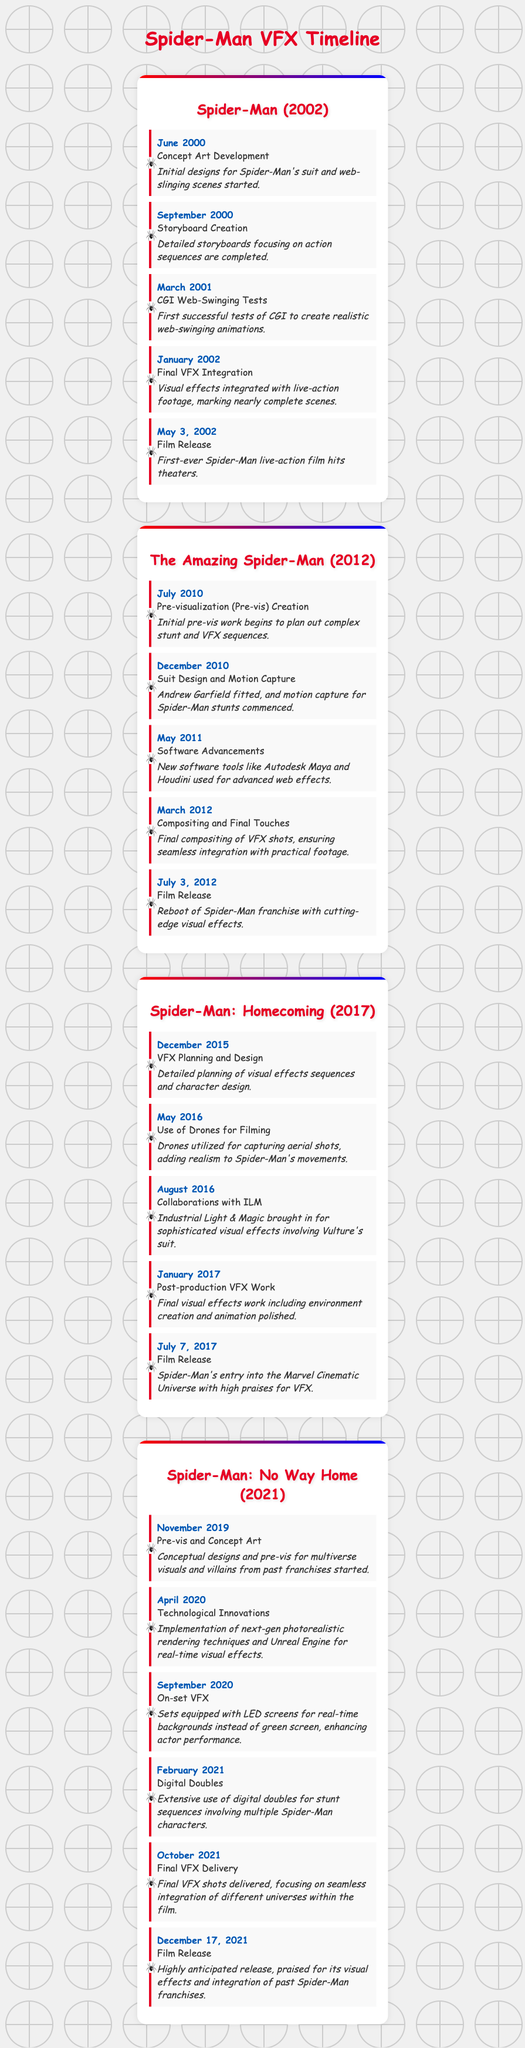What was the film release date for Spider-Man (2002)? The document states the film release date for Spider-Man (2002) is May 3, 2002.
Answer: May 3, 2002 When did CGI web-swinging tests occur for Spider-Man (2002)? The timeline indicates that CGI web-swinging tests took place in March 2001.
Answer: March 2001 Which Spider-Man film involved extensive use of digital doubles? The document mentions that Spider-Man: No Way Home (2021) involved extensive use of digital doubles.
Answer: Spider-Man: No Way Home (2021) What was a key milestone in The Amazing Spider-Man (2012) related to software? The relevant milestone is about new software tools being used, mentioned in May 2011.
Answer: Software Advancements How many Spider-Man movies are covered in the timeline? The timeline covers four movies, each with its own milestones and key dates.
Answer: Four What key tool was used for real-time visual effects in Spider-Man: No Way Home (2021)? The document highlights the use of Unreal Engine for real-time visual effects as a key tool.
Answer: Unreal Engine What significant event occurred in April 2020 for Spider-Man: No Way Home (2021)? The document states that technological innovations were implemented in April 2020.
Answer: Technological Innovations Which film's release was highly praised for its visual effects? According to the document, Spider-Man: No Way Home (2021) received high praise for its visual effects.
Answer: Spider-Man: No Way Home (2021) 